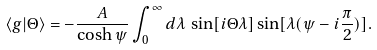<formula> <loc_0><loc_0><loc_500><loc_500>\langle g | \Theta \rangle = - \frac { A } { \cosh \psi } \int _ { 0 } ^ { \infty } d \lambda \, \sin [ i \Theta \lambda ] \sin [ \lambda ( \psi - i { \frac { \pi } { 2 } } ) ] .</formula> 